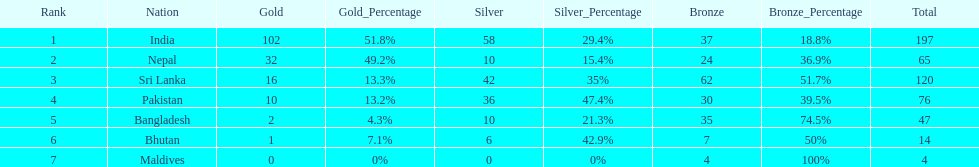Parse the full table. {'header': ['Rank', 'Nation', 'Gold', 'Gold_Percentage', 'Silver', 'Silver_Percentage', 'Bronze', 'Bronze_Percentage', 'Total'], 'rows': [['1', 'India', '102', '51.8%', '58', '29.4%', '37', '18.8%', '197'], ['2', 'Nepal', '32', '49.2%', '10', '15.4%', '24', '36.9%', '65'], ['3', 'Sri Lanka', '16', '13.3%', '42', '35%', '62', '51.7%', '120'], ['4', 'Pakistan', '10', '13.2%', '36', '47.4%', '30', '39.5%', '76'], ['5', 'Bangladesh', '2', '4.3%', '10', '21.3%', '35', '74.5%', '47'], ['6', 'Bhutan', '1', '7.1%', '6', '42.9%', '7', '50%', '14'], ['7', 'Maldives', '0', '0%', '0', '0%', '4', '100%', '4']]} How many gold medals were awarded between all 7 nations? 163. 